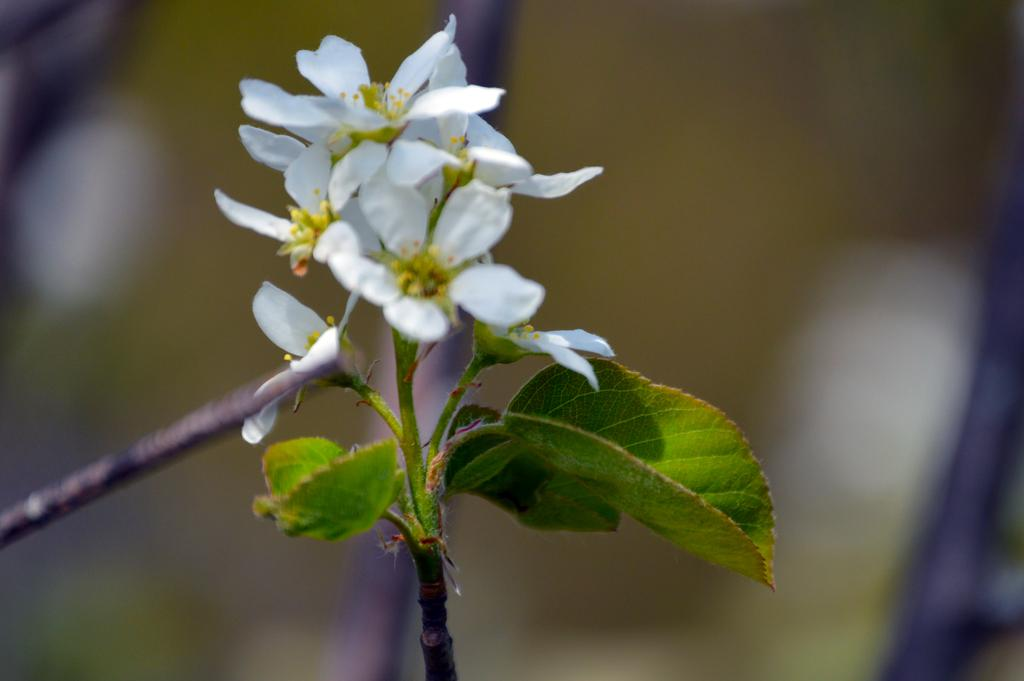What is the main subject of the picture? The main subject of the picture is a plant. What features can be observed on the plant? The plant has leaves and flowers. Can you describe the background of the image? The background of the image is blurred. How many basketballs can be seen in the image? There are no basketballs present in the image. What type of breath is visible in the image? There is no breath visible in the image. 